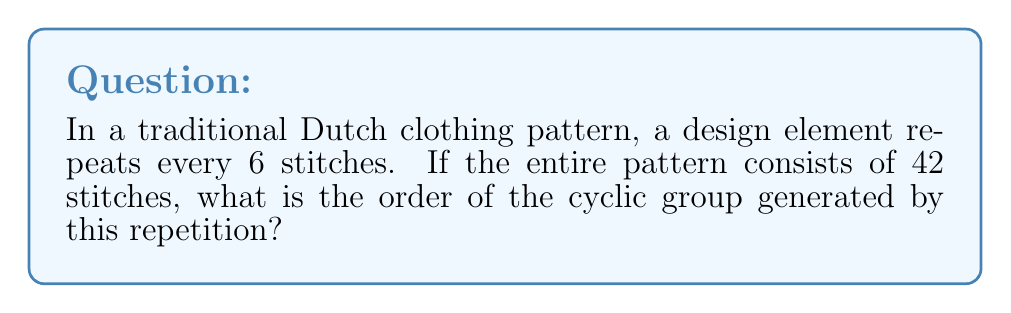Give your solution to this math problem. To solve this problem, we need to understand the concept of cyclic groups and how it applies to pattern repetition in clothing design.

1) First, let's define our cyclic group. The generator of our group is the design element that repeats every 6 stitches. We can call this generator $a$.

2) The order of a cyclic group is the smallest positive integer $n$ such that $a^n = e$, where $e$ is the identity element (in this case, returning to the starting point of the pattern).

3) In our pattern, we need to find how many times the design element needs to repeat to complete the entire pattern. We can calculate this by dividing the total number of stitches by the number of stitches in each repetition:

   $$ \text{Number of repetitions} = \frac{\text{Total stitches}}{\text{Stitches per repetition}} = \frac{42}{6} = 7 $$

4) This means that after 7 repetitions, we return to the starting point of the pattern. In group theory terms:

   $$ a^7 = e $$

5) Therefore, the order of the cyclic group is 7.

This concept is particularly relevant in fashion design, especially when working with traditional patterns. Understanding the mathematical structure behind pattern repetitions can help in creating cohesive and balanced designs while maintaining traditional elements.
Answer: The order of the cyclic group is 7. 